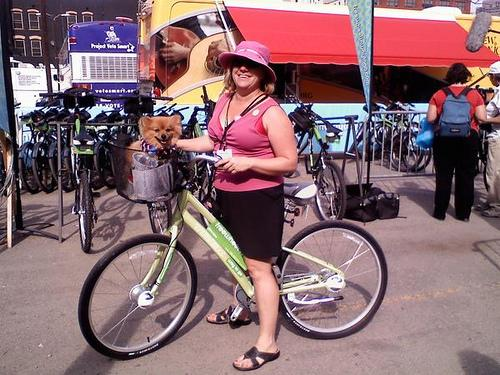Which wrong accessory has the woman worn for riding bike?

Choices:
A) shoes
B) hat
C) sunglasses
D) name tag shoes 